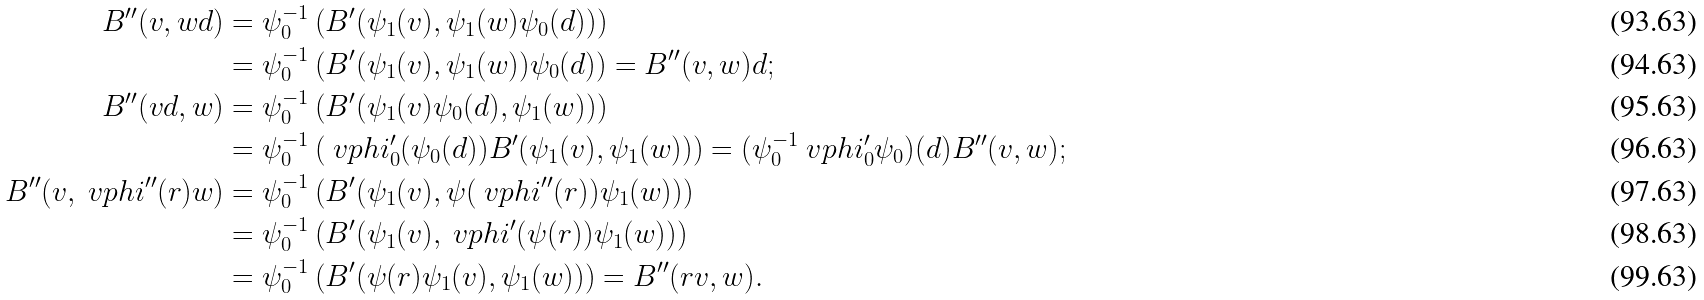Convert formula to latex. <formula><loc_0><loc_0><loc_500><loc_500>B ^ { \prime \prime } ( v , w d ) & = \psi _ { 0 } ^ { - 1 } \left ( B ^ { \prime } ( \psi _ { 1 } ( v ) , \psi _ { 1 } ( w ) \psi _ { 0 } ( d ) ) \right ) \\ & = \psi _ { 0 } ^ { - 1 } \left ( B ^ { \prime } ( \psi _ { 1 } ( v ) , \psi _ { 1 } ( w ) ) \psi _ { 0 } ( d ) \right ) = B ^ { \prime \prime } ( v , w ) d ; \\ B ^ { \prime \prime } ( v d , w ) & = \psi _ { 0 } ^ { - 1 } \left ( B ^ { \prime } ( \psi _ { 1 } ( v ) \psi _ { 0 } ( d ) , \psi _ { 1 } ( w ) ) \right ) \\ & = \psi _ { 0 } ^ { - 1 } \left ( \ v p h i ^ { \prime } _ { 0 } ( \psi _ { 0 } ( d ) ) B ^ { \prime } ( \psi _ { 1 } ( v ) , \psi _ { 1 } ( w ) ) \right ) = ( \psi _ { 0 } ^ { - 1 } \ v p h i ^ { \prime } _ { 0 } \psi _ { 0 } ) ( d ) B ^ { \prime \prime } ( v , w ) ; \\ B ^ { \prime \prime } ( v , \ v p h i ^ { \prime \prime } ( r ) w ) & = \psi _ { 0 } ^ { - 1 } \left ( B ^ { \prime } ( \psi _ { 1 } ( v ) , \psi ( \ v p h i ^ { \prime \prime } ( r ) ) \psi _ { 1 } ( w ) ) \right ) \\ & = \psi _ { 0 } ^ { - 1 } \left ( B ^ { \prime } ( \psi _ { 1 } ( v ) , \ v p h i ^ { \prime } ( \psi ( r ) ) \psi _ { 1 } ( w ) ) \right ) \\ & = \psi _ { 0 } ^ { - 1 } \left ( B ^ { \prime } ( \psi ( r ) \psi _ { 1 } ( v ) , \psi _ { 1 } ( w ) ) \right ) = B ^ { \prime \prime } ( r v , w ) .</formula> 